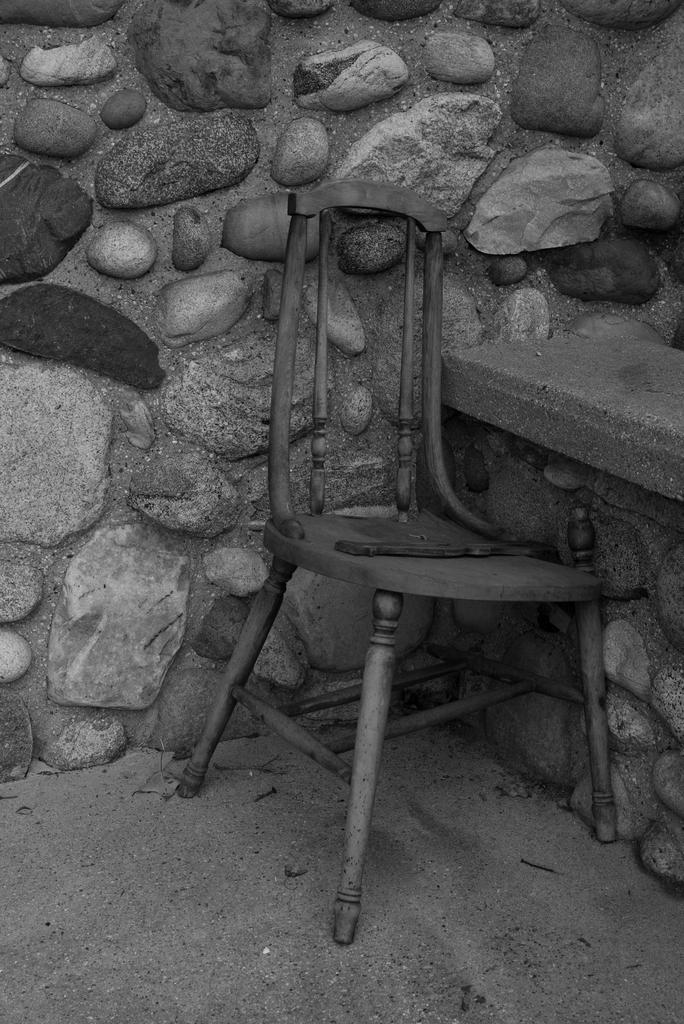What type of picture is in the image? The image contains a black and white picture. What is featured in the black and white picture? There is a chair in the black and white picture. Where is the chair located in the picture? The chair is on the floor in the picture. What can be seen in the background of the black and white picture? There is a wall in the background of the black and white picture. What is the wall made of? The wall is made up of rocks. What type of nut is being cracked by the creator in the image? There is no nut or creator present in the image; it features a black and white picture of a chair on the floor with a rock wall in the background. 